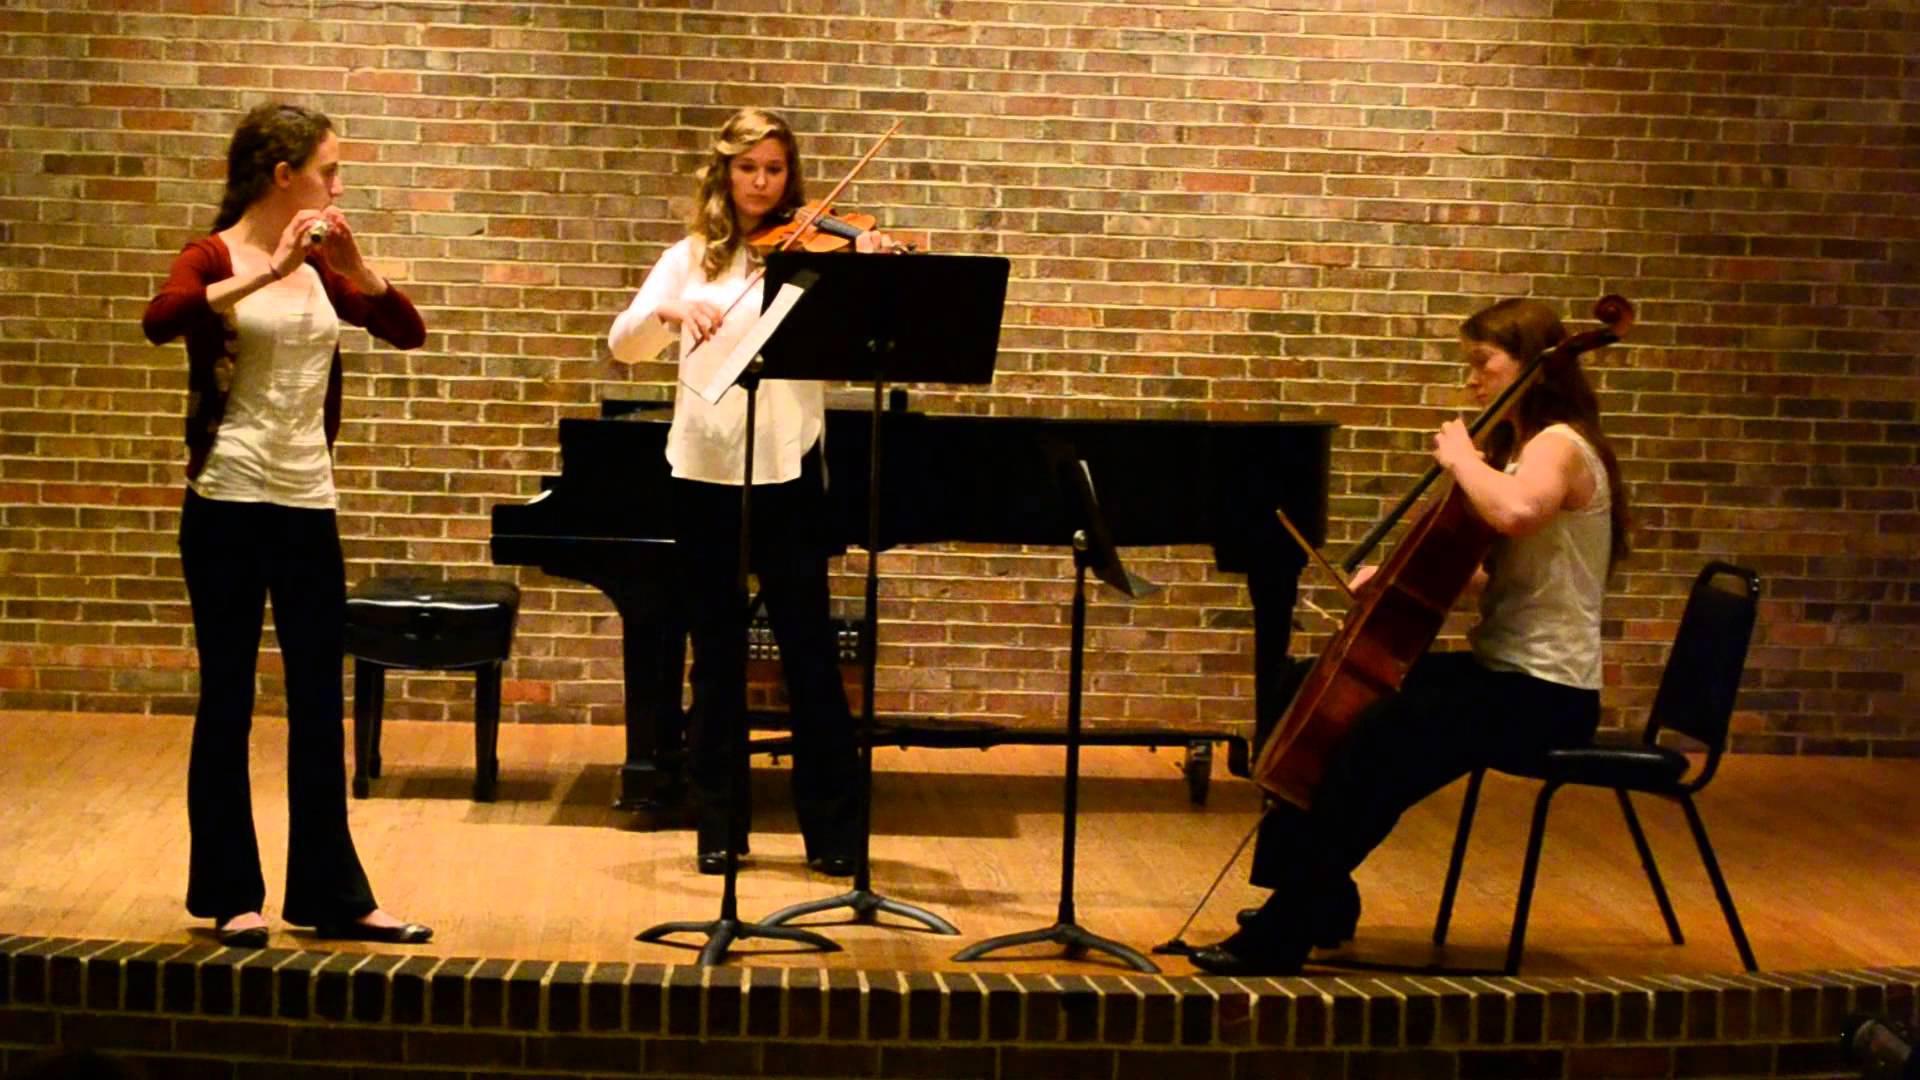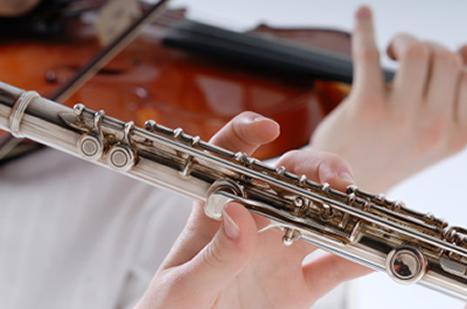The first image is the image on the left, the second image is the image on the right. Analyze the images presented: Is the assertion "The left image contains three humans on a stage playing musical instruments." valid? Answer yes or no. Yes. The first image is the image on the left, the second image is the image on the right. For the images shown, is this caption "The left image shows a trio of musicians on a stage, with the person on the far left standing playing a wind instrument and the person on the far right sitting playing a string instrument." true? Answer yes or no. Yes. 